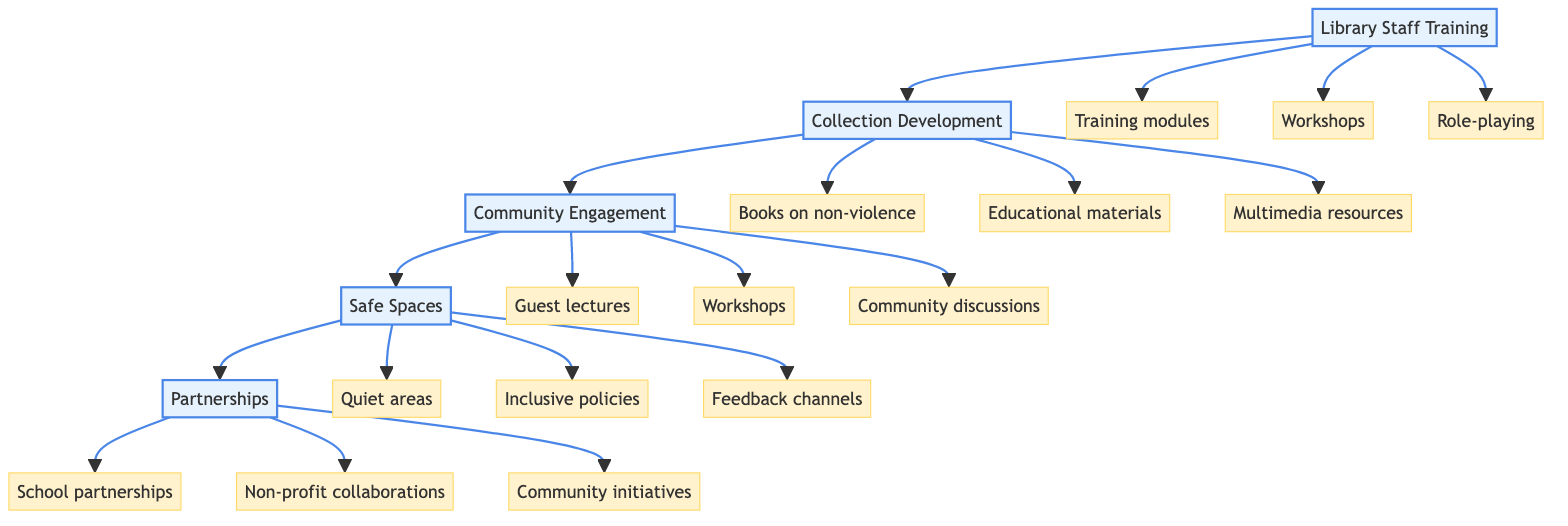What is the first step in the pathway? The first step is indicated at the top of the diagram, labeled "Library Staff Training." This can be identified by examining the starting point of the flow.
Answer: Library Staff Training How many elements are under "Collection Development"? To find the number of elements, you can count the sub-items listed under "Collection Development." There are three elements shown leading from that step.
Answer: 3 Which step involves creating safe spaces? By tracing through the diagram, "Safe Spaces" is directly connected to the previous step "Community Engagement." This title matches the specific focus on safe and inclusive environments.
Answer: Safe Spaces What type of organizations should librarians collaborate with? The step titled "Partnerships" explicitly points to organizations focused on peace and education, as seen in the elements listed under that step.
Answer: Organizations that promote peace and education What is one type of training module suggested for library staff? Examining the elements under "Library Staff Training," you can see specific modules mentioned, including those from the "Non-Violent Crisis Intervention Institute." This title represents a specific module or program being suggested.
Answer: Training modules from the Non-Violent Crisis Intervention Institute Which step follows "Community Engagement"? By following the directional arrows in the flowchart, you can see that "Safe Spaces" comes directly after "Community Engagement," making it the subsequent step.
Answer: Safe Spaces How many guest lectures are mentioned in the "Community Engagement" step? In the diagram, there is one element specifically labeled "Guest lectures" listed under "Community Engagement," indicating a single mention.
Answer: 1 What is the goal of "Collection Development"? The description of "Collection Development" highlights curating a collection that promotes peace and non-violence, which clarifies the primary aim of this step.
Answer: Promote peace and non-violence 